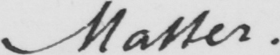What does this handwritten line say? matter . 